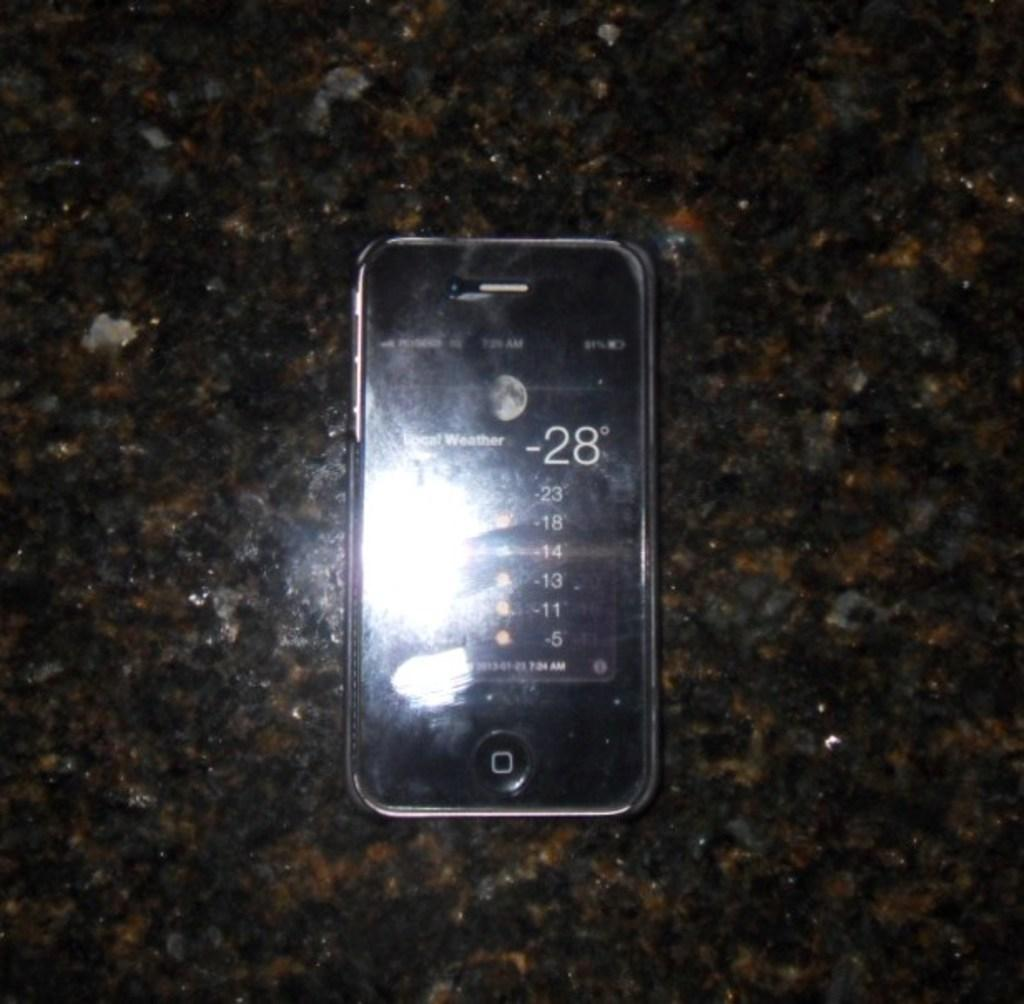<image>
Render a clear and concise summary of the photo. a phone with the number -28 on it 